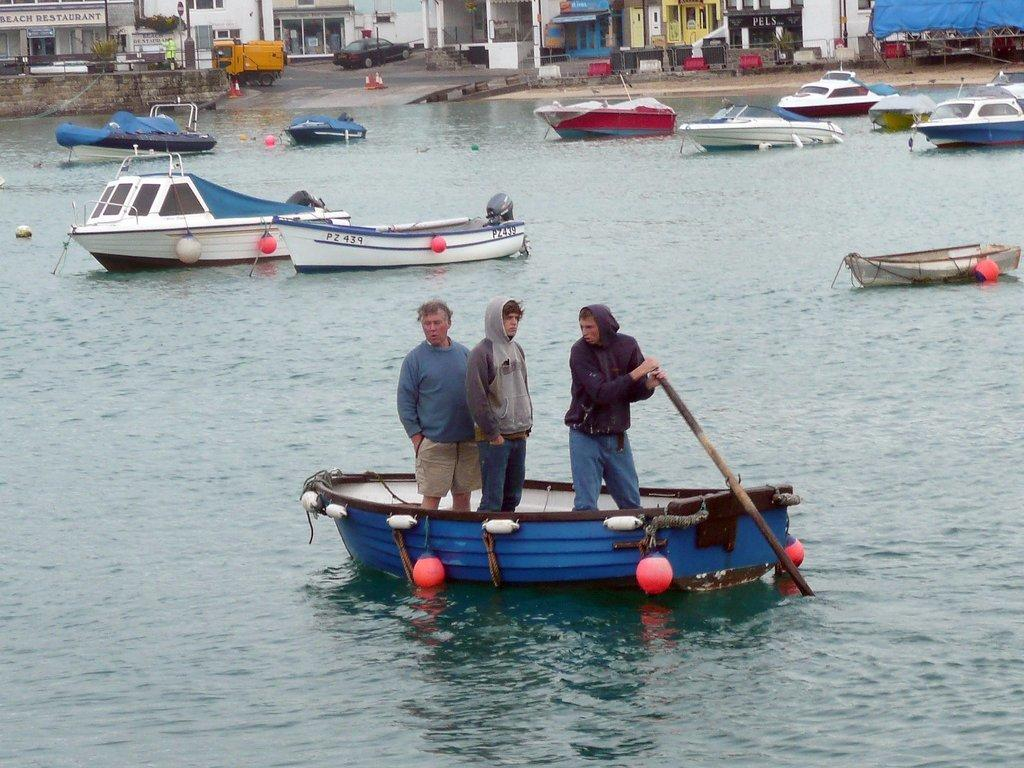What are the people in the image doing? The people in the image are standing on a boat. How many boats can be seen in the image? There are multiple boats on the water. What can be seen in the background of the image? There are vehicles and buildings with boards visible in the background. What type of vegetation is visible in the background? There is a plant visible in the background. What letters are being used to brush the teeth of the people on the boat in the image? There are no letters or teeth present in the image; it features people standing on a boat and other boats on the water. 